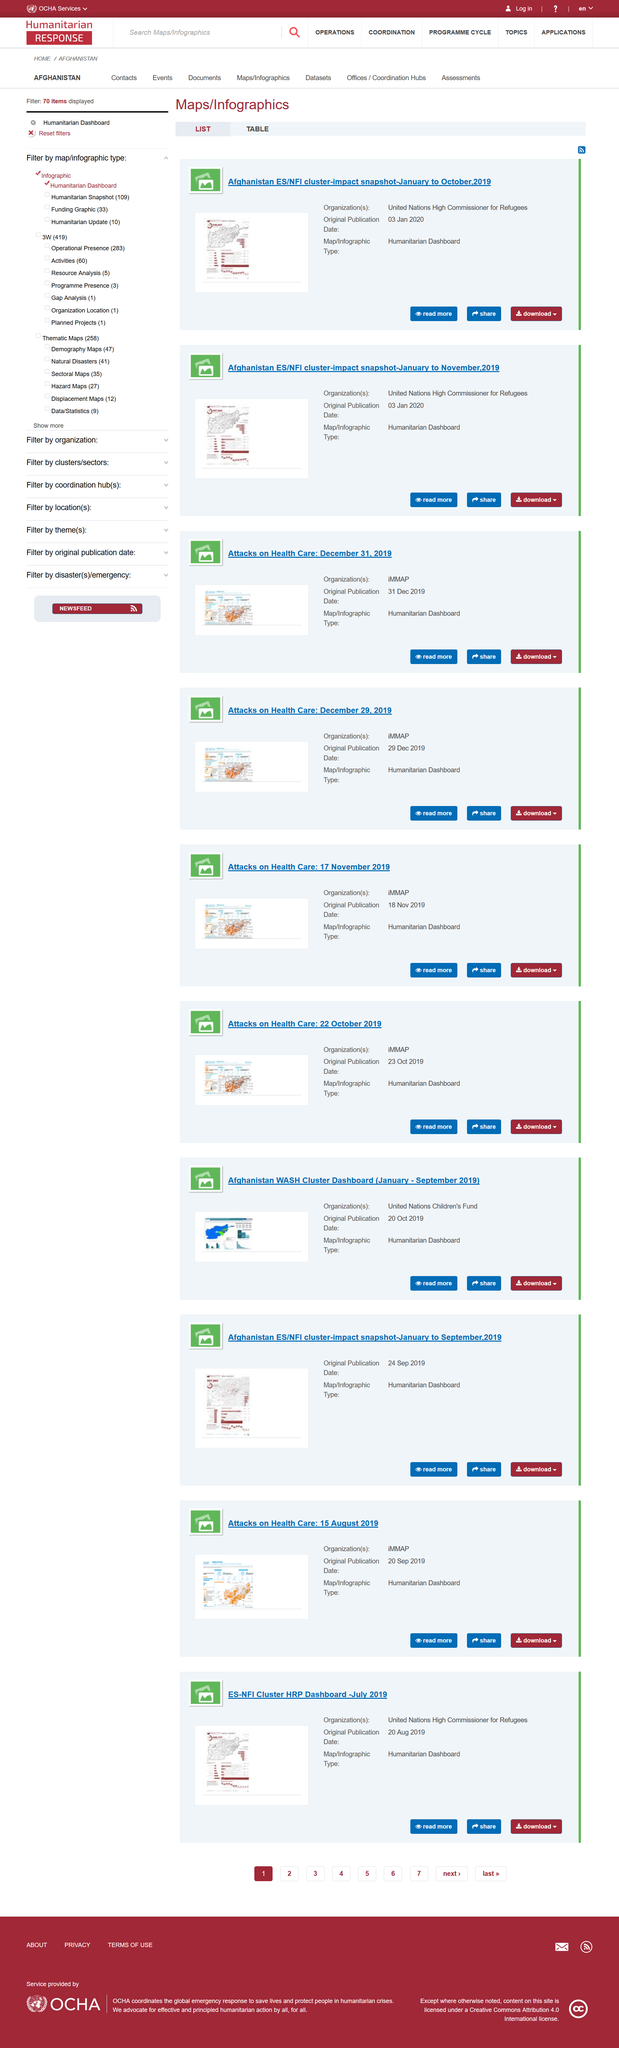Point out several critical features in this image. iMMAP produced a Humanitarian Dashboard, which is a type of map/infographic that provides information on various humanitarian topics such as situational analysis, response planning, and resource tracking. iMMAP was the organization behind the "attacks on health care" presentation. On August 20, 2019, the United Nations High Commissioner for Refugees released a dashboard. All three presentations share a common characteristic, as they feature the use of the "Humanitarian Dashboard" map/infographic type. The dashboard titled "Afghanistan" was published on September 24th, 2019, and it is located in a country with the same name. 